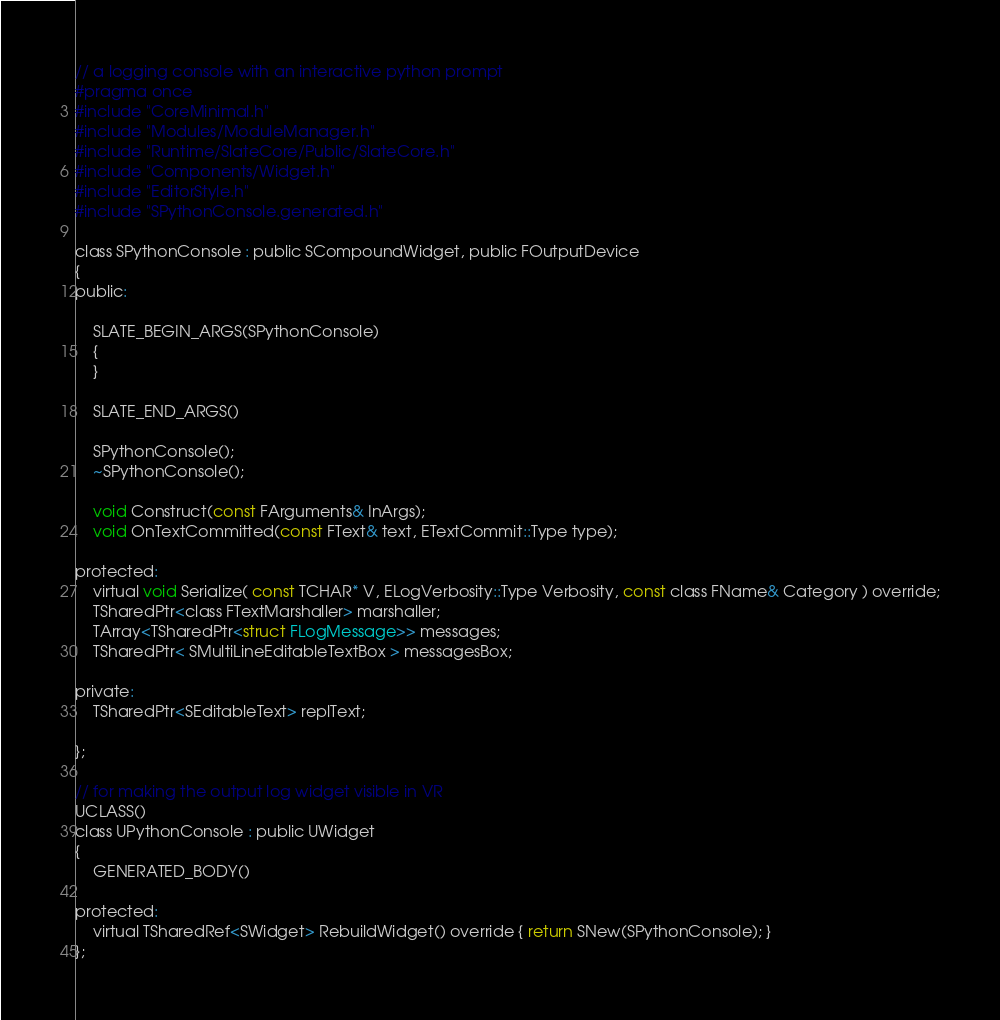<code> <loc_0><loc_0><loc_500><loc_500><_C_>// a logging console with an interactive python prompt
#pragma once
#include "CoreMinimal.h"
#include "Modules/ModuleManager.h"
#include "Runtime/SlateCore/Public/SlateCore.h"
#include "Components/Widget.h"
#include "EditorStyle.h"
#include "SPythonConsole.generated.h"

class SPythonConsole : public SCompoundWidget, public FOutputDevice
{
public:

	SLATE_BEGIN_ARGS(SPythonConsole)
	{
	}

	SLATE_END_ARGS()

    SPythonConsole();
    ~SPythonConsole();

    void Construct(const FArguments& InArgs);
    void OnTextCommitted(const FText& text, ETextCommit::Type type);

protected:
	virtual void Serialize( const TCHAR* V, ELogVerbosity::Type Verbosity, const class FName& Category ) override;
    TSharedPtr<class FTextMarshaller> marshaller;
	TArray<TSharedPtr<struct FLogMessage>> messages;
	TSharedPtr< SMultiLineEditableTextBox > messagesBox;

private:
	TSharedPtr<SEditableText> replText;

};

// for making the output log widget visible in VR
UCLASS()
class UPythonConsole : public UWidget
{
    GENERATED_BODY()

protected:
    virtual TSharedRef<SWidget> RebuildWidget() override { return SNew(SPythonConsole); }
};



</code> 